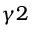<formula> <loc_0><loc_0><loc_500><loc_500>\gamma 2</formula> 